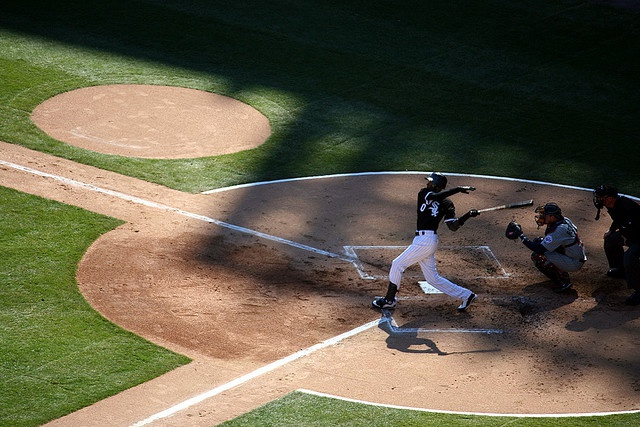Describe the objects in this image and their specific colors. I can see people in black, darkgray, and gray tones, people in black, gray, navy, and maroon tones, people in black and gray tones, baseball bat in black, gray, and darkgray tones, and baseball glove in black and gray tones in this image. 